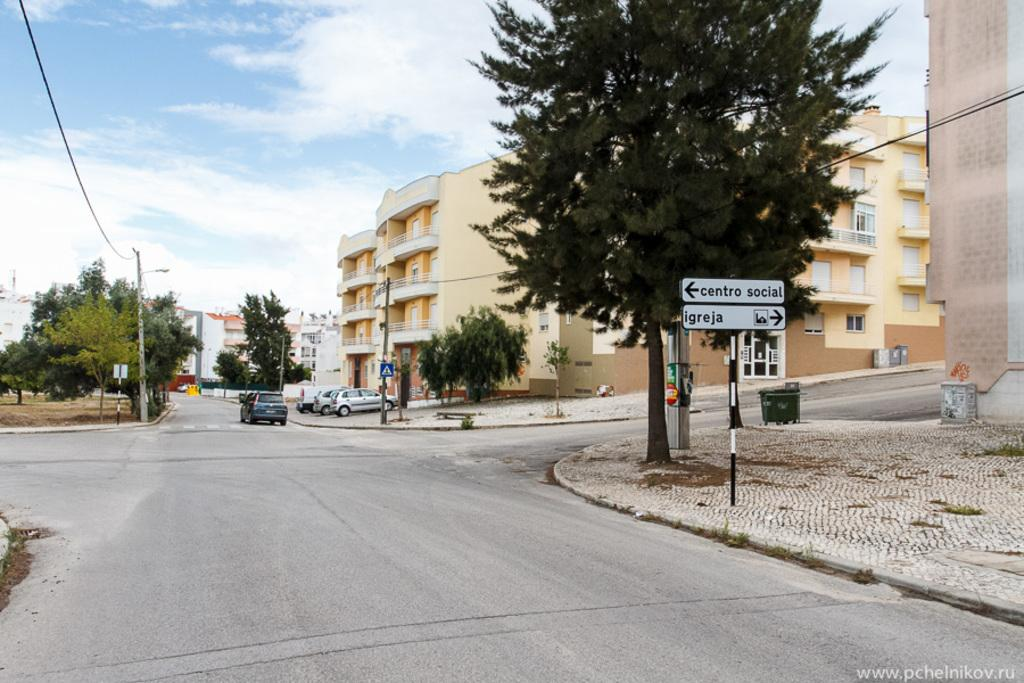What is the main feature of the image? There is a road in the image. What can be seen on the right side of the road? There is a sign board and a tree on the right side of the road. What else is visible in the image besides the road and the objects on the right side? There are buildings visible in the image. What is visible at the top of the image? The sky is visible at the top of the image. What type of magic is being performed by the face on the sign board? There is no face on the sign board, nor is any magic being performed in the image. 